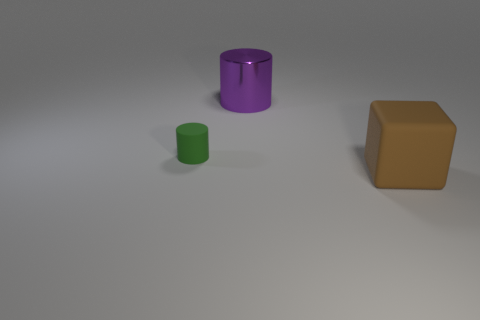Add 2 big brown things. How many objects exist? 5 Subtract all cylinders. How many objects are left? 1 Add 3 small metal balls. How many small metal balls exist? 3 Subtract 0 blue spheres. How many objects are left? 3 Subtract all green cylinders. Subtract all large purple things. How many objects are left? 1 Add 1 large brown blocks. How many large brown blocks are left? 2 